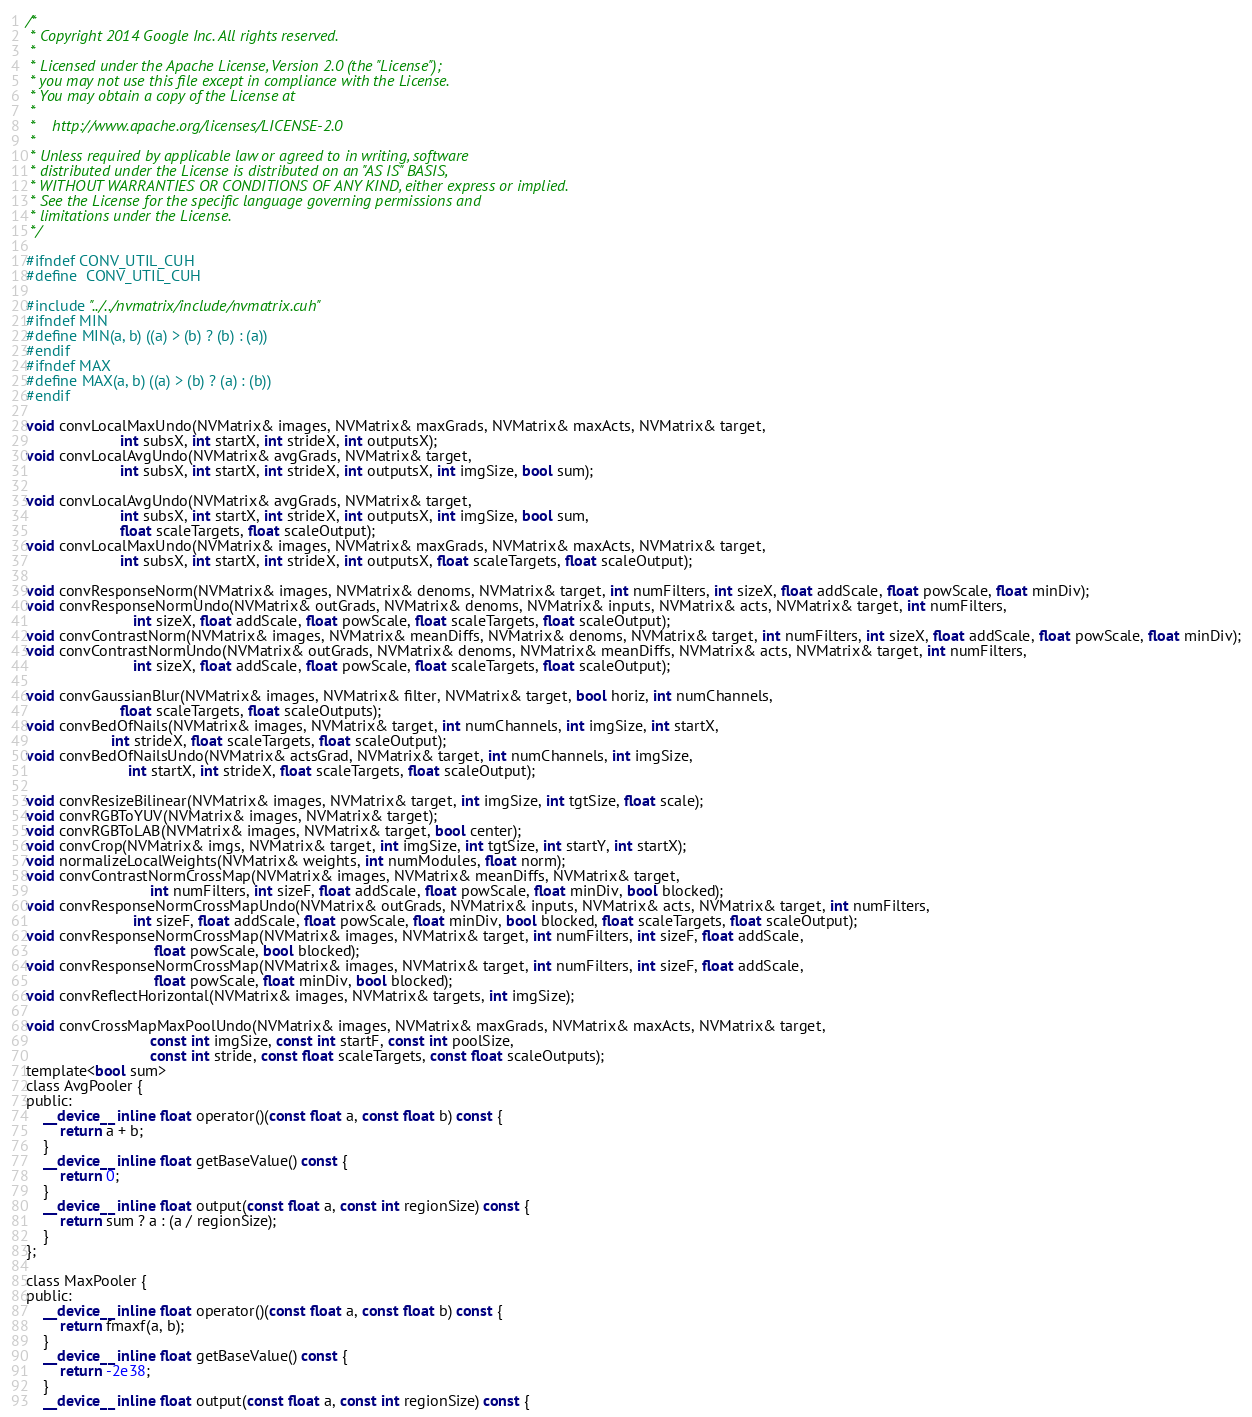<code> <loc_0><loc_0><loc_500><loc_500><_Cuda_>/*
 * Copyright 2014 Google Inc. All rights reserved.
 *
 * Licensed under the Apache License, Version 2.0 (the "License");
 * you may not use this file except in compliance with the License.
 * You may obtain a copy of the License at
 *
 *    http://www.apache.org/licenses/LICENSE-2.0
 *
 * Unless required by applicable law or agreed to in writing, software
 * distributed under the License is distributed on an "AS IS" BASIS,
 * WITHOUT WARRANTIES OR CONDITIONS OF ANY KIND, either express or implied.
 * See the License for the specific language governing permissions and
 * limitations under the License.
 */

#ifndef CONV_UTIL_CUH
#define	CONV_UTIL_CUH

#include "../../nvmatrix/include/nvmatrix.cuh"
#ifndef MIN
#define MIN(a, b) ((a) > (b) ? (b) : (a))
#endif
#ifndef MAX
#define MAX(a, b) ((a) > (b) ? (a) : (b))
#endif

void convLocalMaxUndo(NVMatrix& images, NVMatrix& maxGrads, NVMatrix& maxActs, NVMatrix& target,
                      int subsX, int startX, int strideX, int outputsX);
void convLocalAvgUndo(NVMatrix& avgGrads, NVMatrix& target,
                      int subsX, int startX, int strideX, int outputsX, int imgSize, bool sum);

void convLocalAvgUndo(NVMatrix& avgGrads, NVMatrix& target,
                      int subsX, int startX, int strideX, int outputsX, int imgSize, bool sum,
                      float scaleTargets, float scaleOutput);
void convLocalMaxUndo(NVMatrix& images, NVMatrix& maxGrads, NVMatrix& maxActs, NVMatrix& target,
                      int subsX, int startX, int strideX, int outputsX, float scaleTargets, float scaleOutput);

void convResponseNorm(NVMatrix& images, NVMatrix& denoms, NVMatrix& target, int numFilters, int sizeX, float addScale, float powScale, float minDiv);
void convResponseNormUndo(NVMatrix& outGrads, NVMatrix& denoms, NVMatrix& inputs, NVMatrix& acts, NVMatrix& target, int numFilters,
                         int sizeX, float addScale, float powScale, float scaleTargets, float scaleOutput);
void convContrastNorm(NVMatrix& images, NVMatrix& meanDiffs, NVMatrix& denoms, NVMatrix& target, int numFilters, int sizeX, float addScale, float powScale, float minDiv);
void convContrastNormUndo(NVMatrix& outGrads, NVMatrix& denoms, NVMatrix& meanDiffs, NVMatrix& acts, NVMatrix& target, int numFilters,
                         int sizeX, float addScale, float powScale, float scaleTargets, float scaleOutput);

void convGaussianBlur(NVMatrix& images, NVMatrix& filter, NVMatrix& target, bool horiz, int numChannels,
                      float scaleTargets, float scaleOutputs);
void convBedOfNails(NVMatrix& images, NVMatrix& target, int numChannels, int imgSize, int startX,
                    int strideX, float scaleTargets, float scaleOutput);
void convBedOfNailsUndo(NVMatrix& actsGrad, NVMatrix& target, int numChannels, int imgSize,
                        int startX, int strideX, float scaleTargets, float scaleOutput);

void convResizeBilinear(NVMatrix& images, NVMatrix& target, int imgSize, int tgtSize, float scale);
void convRGBToYUV(NVMatrix& images, NVMatrix& target);
void convRGBToLAB(NVMatrix& images, NVMatrix& target, bool center);
void convCrop(NVMatrix& imgs, NVMatrix& target, int imgSize, int tgtSize, int startY, int startX);
void normalizeLocalWeights(NVMatrix& weights, int numModules, float norm);
void convContrastNormCrossMap(NVMatrix& images, NVMatrix& meanDiffs, NVMatrix& target,
                             int numFilters, int sizeF, float addScale, float powScale, float minDiv, bool blocked);
void convResponseNormCrossMapUndo(NVMatrix& outGrads, NVMatrix& inputs, NVMatrix& acts, NVMatrix& target, int numFilters,
                         int sizeF, float addScale, float powScale, float minDiv, bool blocked, float scaleTargets, float scaleOutput);
void convResponseNormCrossMap(NVMatrix& images, NVMatrix& target, int numFilters, int sizeF, float addScale,
                              float powScale, bool blocked);
void convResponseNormCrossMap(NVMatrix& images, NVMatrix& target, int numFilters, int sizeF, float addScale,
                              float powScale, float minDiv, bool blocked);
void convReflectHorizontal(NVMatrix& images, NVMatrix& targets, int imgSize);

void convCrossMapMaxPoolUndo(NVMatrix& images, NVMatrix& maxGrads, NVMatrix& maxActs, NVMatrix& target,
                             const int imgSize, const int startF, const int poolSize,
                             const int stride, const float scaleTargets, const float scaleOutputs);
template<bool sum>
class AvgPooler {
public:
    __device__ inline float operator()(const float a, const float b) const {
        return a + b;
    }
    __device__ inline float getBaseValue() const {
        return 0;
    }
    __device__ inline float output(const float a, const int regionSize) const {
        return sum ? a : (a / regionSize);
    }
};

class MaxPooler {
public:
    __device__ inline float operator()(const float a, const float b) const {
        return fmaxf(a, b);
    }
    __device__ inline float getBaseValue() const {
        return -2e38;
    }
    __device__ inline float output(const float a, const int regionSize) const {</code> 